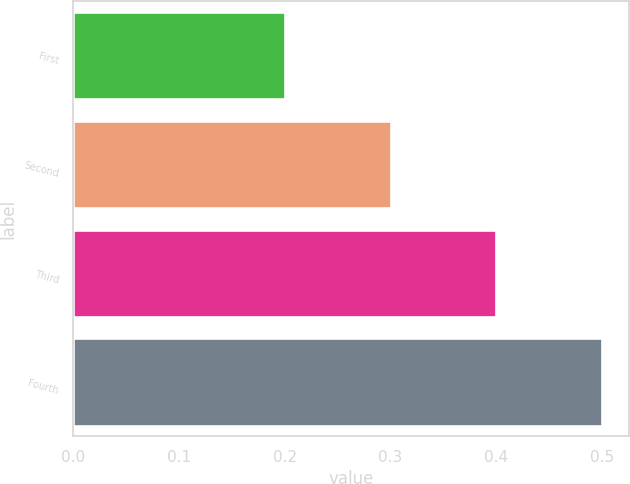Convert chart. <chart><loc_0><loc_0><loc_500><loc_500><bar_chart><fcel>First<fcel>Second<fcel>Third<fcel>Fourth<nl><fcel>0.2<fcel>0.3<fcel>0.4<fcel>0.5<nl></chart> 